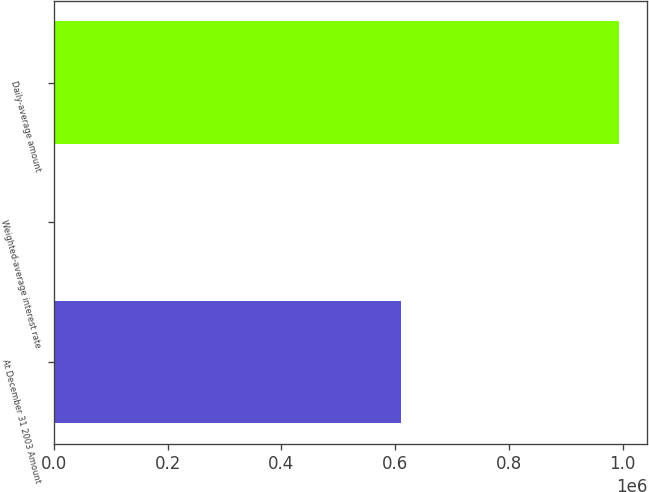<chart> <loc_0><loc_0><loc_500><loc_500><bar_chart><fcel>At December 31 2003 Amount<fcel>Weighted-average interest rate<fcel>Daily-average amount<nl><fcel>610064<fcel>1.25<fcel>993235<nl></chart> 